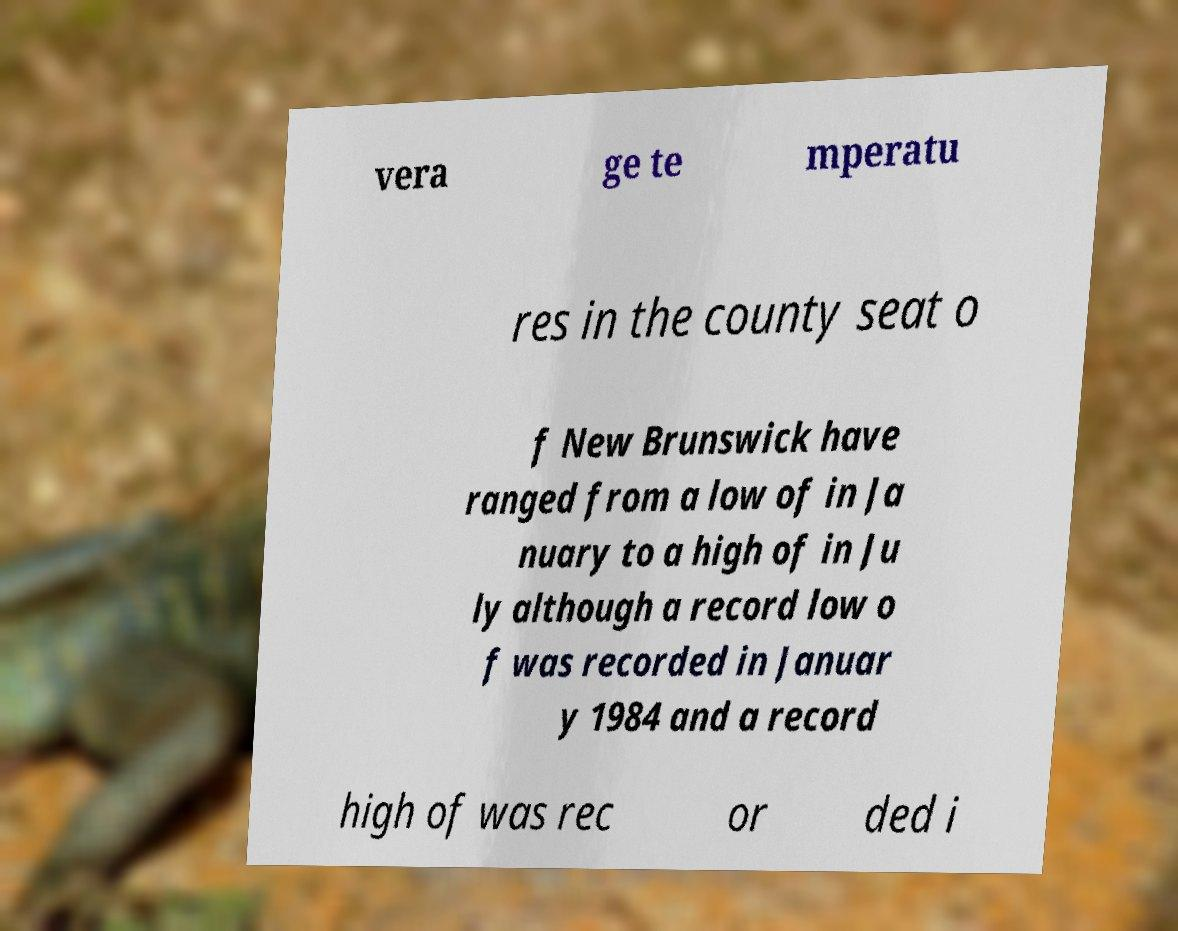What messages or text are displayed in this image? I need them in a readable, typed format. vera ge te mperatu res in the county seat o f New Brunswick have ranged from a low of in Ja nuary to a high of in Ju ly although a record low o f was recorded in Januar y 1984 and a record high of was rec or ded i 